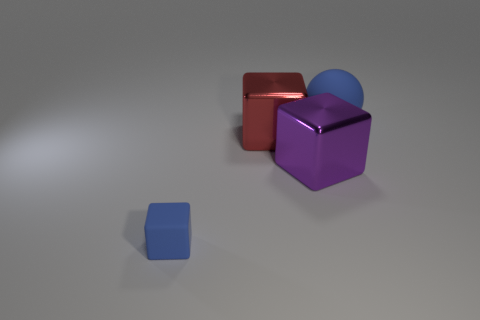What number of other large purple things are the same shape as the big purple metallic thing?
Make the answer very short. 0. Are there an equal number of red things behind the big blue matte thing and big shiny cubes?
Your answer should be very brief. No. The sphere that is the same size as the purple thing is what color?
Your response must be concise. Blue. Are there any large purple things of the same shape as the tiny matte thing?
Keep it short and to the point. Yes. There is a blue object in front of the blue ball behind the big purple cube in front of the big blue rubber sphere; what is it made of?
Provide a short and direct response. Rubber. What number of other objects are the same size as the red metal block?
Your response must be concise. 2. What color is the small rubber cube?
Give a very brief answer. Blue. What number of matte things are either red spheres or purple cubes?
Offer a very short reply. 0. There is a blue rubber thing that is in front of the large purple block in front of the rubber thing behind the tiny blue rubber object; how big is it?
Offer a terse response. Small. What size is the block that is both in front of the big red metal thing and behind the small blue block?
Provide a succinct answer. Large. 